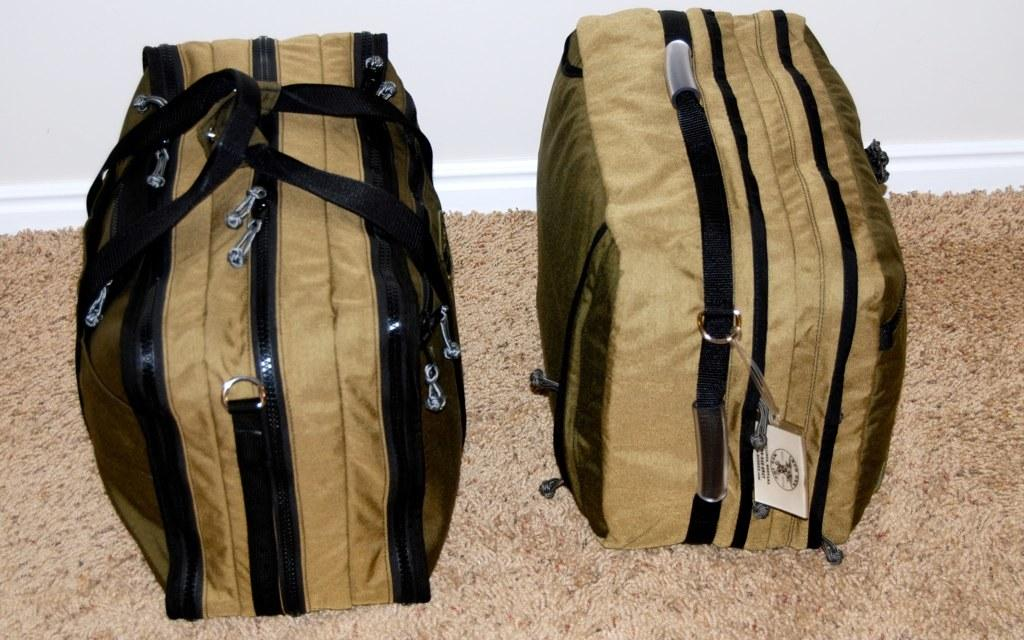What objects are on the floor carpet in the image? There are two bags on the floor carpet in the image. What else can be seen in the image besides the bags? There is a wall visible in the image. What type of paste is being used to hold the bags together in the image? There is no paste visible in the image, and the bags are not being held together. 